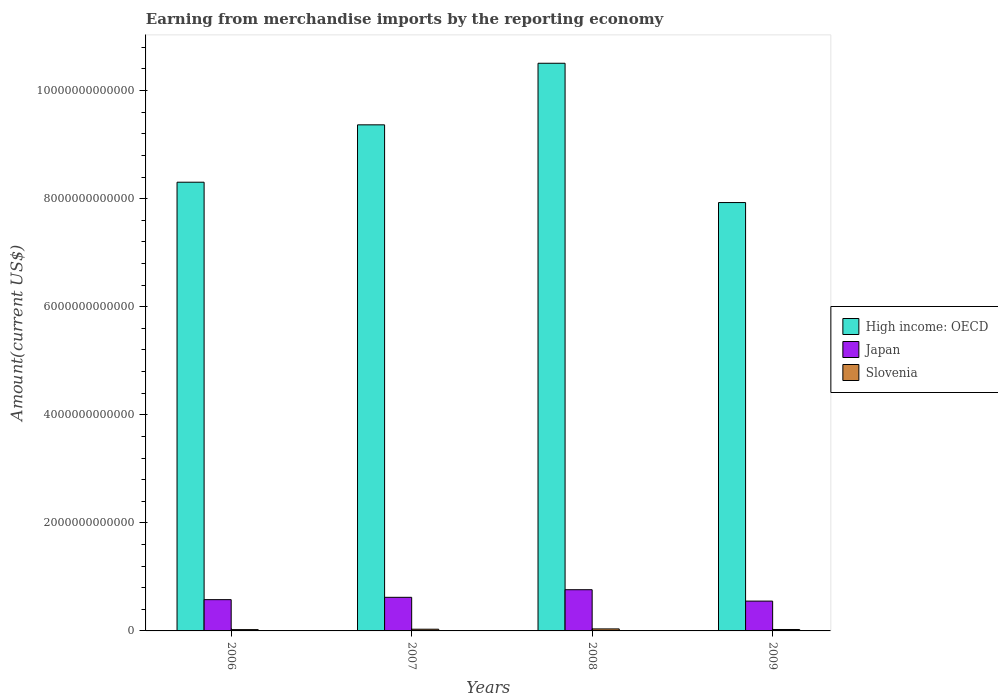Are the number of bars on each tick of the X-axis equal?
Provide a succinct answer. Yes. What is the label of the 2nd group of bars from the left?
Your answer should be very brief. 2007. What is the amount earned from merchandise imports in High income: OECD in 2009?
Provide a succinct answer. 7.93e+12. Across all years, what is the maximum amount earned from merchandise imports in Slovenia?
Offer a terse response. 3.71e+1. Across all years, what is the minimum amount earned from merchandise imports in Slovenia?
Offer a terse response. 2.42e+1. In which year was the amount earned from merchandise imports in High income: OECD maximum?
Keep it short and to the point. 2008. What is the total amount earned from merchandise imports in Slovenia in the graph?
Provide a short and direct response. 1.19e+11. What is the difference between the amount earned from merchandise imports in High income: OECD in 2006 and that in 2008?
Keep it short and to the point. -2.20e+12. What is the difference between the amount earned from merchandise imports in Slovenia in 2007 and the amount earned from merchandise imports in High income: OECD in 2008?
Offer a terse response. -1.05e+13. What is the average amount earned from merchandise imports in Japan per year?
Offer a terse response. 6.29e+11. In the year 2006, what is the difference between the amount earned from merchandise imports in High income: OECD and amount earned from merchandise imports in Japan?
Give a very brief answer. 7.73e+12. What is the ratio of the amount earned from merchandise imports in Japan in 2006 to that in 2007?
Make the answer very short. 0.93. Is the amount earned from merchandise imports in Japan in 2007 less than that in 2009?
Offer a very short reply. No. What is the difference between the highest and the second highest amount earned from merchandise imports in Slovenia?
Provide a succinct answer. 5.51e+09. What is the difference between the highest and the lowest amount earned from merchandise imports in Slovenia?
Your answer should be very brief. 1.30e+1. What does the 1st bar from the left in 2008 represents?
Make the answer very short. High income: OECD. What does the 2nd bar from the right in 2008 represents?
Provide a short and direct response. Japan. How many years are there in the graph?
Give a very brief answer. 4. What is the difference between two consecutive major ticks on the Y-axis?
Make the answer very short. 2.00e+12. Are the values on the major ticks of Y-axis written in scientific E-notation?
Keep it short and to the point. No. Does the graph contain grids?
Provide a short and direct response. No. Where does the legend appear in the graph?
Give a very brief answer. Center right. How are the legend labels stacked?
Your answer should be very brief. Vertical. What is the title of the graph?
Make the answer very short. Earning from merchandise imports by the reporting economy. Does "Mongolia" appear as one of the legend labels in the graph?
Give a very brief answer. No. What is the label or title of the X-axis?
Give a very brief answer. Years. What is the label or title of the Y-axis?
Ensure brevity in your answer.  Amount(current US$). What is the Amount(current US$) of High income: OECD in 2006?
Keep it short and to the point. 8.30e+12. What is the Amount(current US$) in Japan in 2006?
Ensure brevity in your answer.  5.79e+11. What is the Amount(current US$) in Slovenia in 2006?
Make the answer very short. 2.42e+1. What is the Amount(current US$) in High income: OECD in 2007?
Your answer should be compact. 9.37e+12. What is the Amount(current US$) in Japan in 2007?
Your answer should be very brief. 6.22e+11. What is the Amount(current US$) of Slovenia in 2007?
Offer a very short reply. 3.16e+1. What is the Amount(current US$) in High income: OECD in 2008?
Your answer should be compact. 1.05e+13. What is the Amount(current US$) in Japan in 2008?
Make the answer very short. 7.63e+11. What is the Amount(current US$) of Slovenia in 2008?
Your answer should be very brief. 3.71e+1. What is the Amount(current US$) of High income: OECD in 2009?
Keep it short and to the point. 7.93e+12. What is the Amount(current US$) of Japan in 2009?
Your response must be concise. 5.52e+11. What is the Amount(current US$) of Slovenia in 2009?
Your answer should be very brief. 2.65e+1. Across all years, what is the maximum Amount(current US$) in High income: OECD?
Keep it short and to the point. 1.05e+13. Across all years, what is the maximum Amount(current US$) in Japan?
Provide a short and direct response. 7.63e+11. Across all years, what is the maximum Amount(current US$) in Slovenia?
Offer a terse response. 3.71e+1. Across all years, what is the minimum Amount(current US$) in High income: OECD?
Give a very brief answer. 7.93e+12. Across all years, what is the minimum Amount(current US$) in Japan?
Make the answer very short. 5.52e+11. Across all years, what is the minimum Amount(current US$) in Slovenia?
Provide a succinct answer. 2.42e+1. What is the total Amount(current US$) of High income: OECD in the graph?
Your answer should be very brief. 3.61e+13. What is the total Amount(current US$) in Japan in the graph?
Your response must be concise. 2.52e+12. What is the total Amount(current US$) in Slovenia in the graph?
Your answer should be compact. 1.19e+11. What is the difference between the Amount(current US$) in High income: OECD in 2006 and that in 2007?
Offer a very short reply. -1.06e+12. What is the difference between the Amount(current US$) of Japan in 2006 and that in 2007?
Offer a terse response. -4.32e+1. What is the difference between the Amount(current US$) in Slovenia in 2006 and that in 2007?
Your response must be concise. -7.45e+09. What is the difference between the Amount(current US$) in High income: OECD in 2006 and that in 2008?
Provide a succinct answer. -2.20e+12. What is the difference between the Amount(current US$) in Japan in 2006 and that in 2008?
Ensure brevity in your answer.  -1.84e+11. What is the difference between the Amount(current US$) in Slovenia in 2006 and that in 2008?
Your answer should be very brief. -1.30e+1. What is the difference between the Amount(current US$) in High income: OECD in 2006 and that in 2009?
Provide a succinct answer. 3.77e+11. What is the difference between the Amount(current US$) in Japan in 2006 and that in 2009?
Give a very brief answer. 2.68e+1. What is the difference between the Amount(current US$) of Slovenia in 2006 and that in 2009?
Your response must be concise. -2.35e+09. What is the difference between the Amount(current US$) of High income: OECD in 2007 and that in 2008?
Ensure brevity in your answer.  -1.14e+12. What is the difference between the Amount(current US$) of Japan in 2007 and that in 2008?
Offer a very short reply. -1.41e+11. What is the difference between the Amount(current US$) of Slovenia in 2007 and that in 2008?
Your answer should be very brief. -5.51e+09. What is the difference between the Amount(current US$) in High income: OECD in 2007 and that in 2009?
Give a very brief answer. 1.44e+12. What is the difference between the Amount(current US$) of Japan in 2007 and that in 2009?
Ensure brevity in your answer.  7.00e+1. What is the difference between the Amount(current US$) of Slovenia in 2007 and that in 2009?
Ensure brevity in your answer.  5.10e+09. What is the difference between the Amount(current US$) in High income: OECD in 2008 and that in 2009?
Provide a succinct answer. 2.58e+12. What is the difference between the Amount(current US$) in Japan in 2008 and that in 2009?
Make the answer very short. 2.11e+11. What is the difference between the Amount(current US$) of Slovenia in 2008 and that in 2009?
Your response must be concise. 1.06e+1. What is the difference between the Amount(current US$) in High income: OECD in 2006 and the Amount(current US$) in Japan in 2007?
Keep it short and to the point. 7.68e+12. What is the difference between the Amount(current US$) in High income: OECD in 2006 and the Amount(current US$) in Slovenia in 2007?
Your answer should be compact. 8.27e+12. What is the difference between the Amount(current US$) of Japan in 2006 and the Amount(current US$) of Slovenia in 2007?
Your response must be concise. 5.47e+11. What is the difference between the Amount(current US$) of High income: OECD in 2006 and the Amount(current US$) of Japan in 2008?
Your response must be concise. 7.54e+12. What is the difference between the Amount(current US$) of High income: OECD in 2006 and the Amount(current US$) of Slovenia in 2008?
Provide a succinct answer. 8.27e+12. What is the difference between the Amount(current US$) in Japan in 2006 and the Amount(current US$) in Slovenia in 2008?
Your answer should be very brief. 5.42e+11. What is the difference between the Amount(current US$) in High income: OECD in 2006 and the Amount(current US$) in Japan in 2009?
Keep it short and to the point. 7.75e+12. What is the difference between the Amount(current US$) of High income: OECD in 2006 and the Amount(current US$) of Slovenia in 2009?
Your response must be concise. 8.28e+12. What is the difference between the Amount(current US$) in Japan in 2006 and the Amount(current US$) in Slovenia in 2009?
Provide a succinct answer. 5.52e+11. What is the difference between the Amount(current US$) of High income: OECD in 2007 and the Amount(current US$) of Japan in 2008?
Your answer should be compact. 8.60e+12. What is the difference between the Amount(current US$) in High income: OECD in 2007 and the Amount(current US$) in Slovenia in 2008?
Your answer should be very brief. 9.33e+12. What is the difference between the Amount(current US$) in Japan in 2007 and the Amount(current US$) in Slovenia in 2008?
Offer a terse response. 5.85e+11. What is the difference between the Amount(current US$) in High income: OECD in 2007 and the Amount(current US$) in Japan in 2009?
Keep it short and to the point. 8.81e+12. What is the difference between the Amount(current US$) of High income: OECD in 2007 and the Amount(current US$) of Slovenia in 2009?
Provide a succinct answer. 9.34e+12. What is the difference between the Amount(current US$) in Japan in 2007 and the Amount(current US$) in Slovenia in 2009?
Make the answer very short. 5.95e+11. What is the difference between the Amount(current US$) of High income: OECD in 2008 and the Amount(current US$) of Japan in 2009?
Offer a very short reply. 9.95e+12. What is the difference between the Amount(current US$) in High income: OECD in 2008 and the Amount(current US$) in Slovenia in 2009?
Give a very brief answer. 1.05e+13. What is the difference between the Amount(current US$) of Japan in 2008 and the Amount(current US$) of Slovenia in 2009?
Your answer should be compact. 7.36e+11. What is the average Amount(current US$) in High income: OECD per year?
Your answer should be very brief. 9.03e+12. What is the average Amount(current US$) of Japan per year?
Keep it short and to the point. 6.29e+11. What is the average Amount(current US$) of Slovenia per year?
Your answer should be compact. 2.99e+1. In the year 2006, what is the difference between the Amount(current US$) of High income: OECD and Amount(current US$) of Japan?
Offer a terse response. 7.73e+12. In the year 2006, what is the difference between the Amount(current US$) in High income: OECD and Amount(current US$) in Slovenia?
Provide a short and direct response. 8.28e+12. In the year 2006, what is the difference between the Amount(current US$) in Japan and Amount(current US$) in Slovenia?
Offer a terse response. 5.55e+11. In the year 2007, what is the difference between the Amount(current US$) of High income: OECD and Amount(current US$) of Japan?
Ensure brevity in your answer.  8.74e+12. In the year 2007, what is the difference between the Amount(current US$) of High income: OECD and Amount(current US$) of Slovenia?
Make the answer very short. 9.33e+12. In the year 2007, what is the difference between the Amount(current US$) in Japan and Amount(current US$) in Slovenia?
Your answer should be compact. 5.90e+11. In the year 2008, what is the difference between the Amount(current US$) of High income: OECD and Amount(current US$) of Japan?
Offer a terse response. 9.74e+12. In the year 2008, what is the difference between the Amount(current US$) of High income: OECD and Amount(current US$) of Slovenia?
Ensure brevity in your answer.  1.05e+13. In the year 2008, what is the difference between the Amount(current US$) of Japan and Amount(current US$) of Slovenia?
Your answer should be compact. 7.25e+11. In the year 2009, what is the difference between the Amount(current US$) of High income: OECD and Amount(current US$) of Japan?
Your response must be concise. 7.38e+12. In the year 2009, what is the difference between the Amount(current US$) of High income: OECD and Amount(current US$) of Slovenia?
Make the answer very short. 7.90e+12. In the year 2009, what is the difference between the Amount(current US$) of Japan and Amount(current US$) of Slovenia?
Your answer should be very brief. 5.25e+11. What is the ratio of the Amount(current US$) in High income: OECD in 2006 to that in 2007?
Your answer should be very brief. 0.89. What is the ratio of the Amount(current US$) in Japan in 2006 to that in 2007?
Your response must be concise. 0.93. What is the ratio of the Amount(current US$) of Slovenia in 2006 to that in 2007?
Offer a very short reply. 0.76. What is the ratio of the Amount(current US$) of High income: OECD in 2006 to that in 2008?
Provide a short and direct response. 0.79. What is the ratio of the Amount(current US$) of Japan in 2006 to that in 2008?
Your answer should be very brief. 0.76. What is the ratio of the Amount(current US$) in Slovenia in 2006 to that in 2008?
Provide a succinct answer. 0.65. What is the ratio of the Amount(current US$) of High income: OECD in 2006 to that in 2009?
Offer a very short reply. 1.05. What is the ratio of the Amount(current US$) in Japan in 2006 to that in 2009?
Your response must be concise. 1.05. What is the ratio of the Amount(current US$) in Slovenia in 2006 to that in 2009?
Make the answer very short. 0.91. What is the ratio of the Amount(current US$) of High income: OECD in 2007 to that in 2008?
Provide a short and direct response. 0.89. What is the ratio of the Amount(current US$) of Japan in 2007 to that in 2008?
Your answer should be very brief. 0.82. What is the ratio of the Amount(current US$) of Slovenia in 2007 to that in 2008?
Provide a succinct answer. 0.85. What is the ratio of the Amount(current US$) in High income: OECD in 2007 to that in 2009?
Make the answer very short. 1.18. What is the ratio of the Amount(current US$) of Japan in 2007 to that in 2009?
Give a very brief answer. 1.13. What is the ratio of the Amount(current US$) in Slovenia in 2007 to that in 2009?
Provide a succinct answer. 1.19. What is the ratio of the Amount(current US$) of High income: OECD in 2008 to that in 2009?
Your response must be concise. 1.33. What is the ratio of the Amount(current US$) in Japan in 2008 to that in 2009?
Provide a short and direct response. 1.38. What is the ratio of the Amount(current US$) in Slovenia in 2008 to that in 2009?
Provide a succinct answer. 1.4. What is the difference between the highest and the second highest Amount(current US$) in High income: OECD?
Your response must be concise. 1.14e+12. What is the difference between the highest and the second highest Amount(current US$) of Japan?
Give a very brief answer. 1.41e+11. What is the difference between the highest and the second highest Amount(current US$) of Slovenia?
Provide a short and direct response. 5.51e+09. What is the difference between the highest and the lowest Amount(current US$) of High income: OECD?
Provide a succinct answer. 2.58e+12. What is the difference between the highest and the lowest Amount(current US$) in Japan?
Make the answer very short. 2.11e+11. What is the difference between the highest and the lowest Amount(current US$) of Slovenia?
Offer a very short reply. 1.30e+1. 